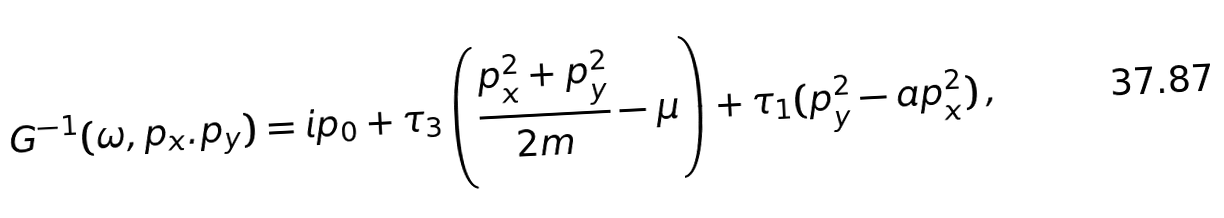Convert formula to latex. <formula><loc_0><loc_0><loc_500><loc_500>G ^ { - 1 } ( \omega , p _ { x } . p _ { y } ) = i p _ { 0 } + \tau _ { 3 } \left ( \frac { p _ { x } ^ { 2 } + p _ { y } ^ { 2 } } { 2 m } - \mu \right ) + \tau _ { 1 } ( p _ { y } ^ { 2 } - a p _ { x } ^ { 2 } ) \, ,</formula> 